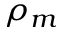<formula> <loc_0><loc_0><loc_500><loc_500>\rho _ { m }</formula> 